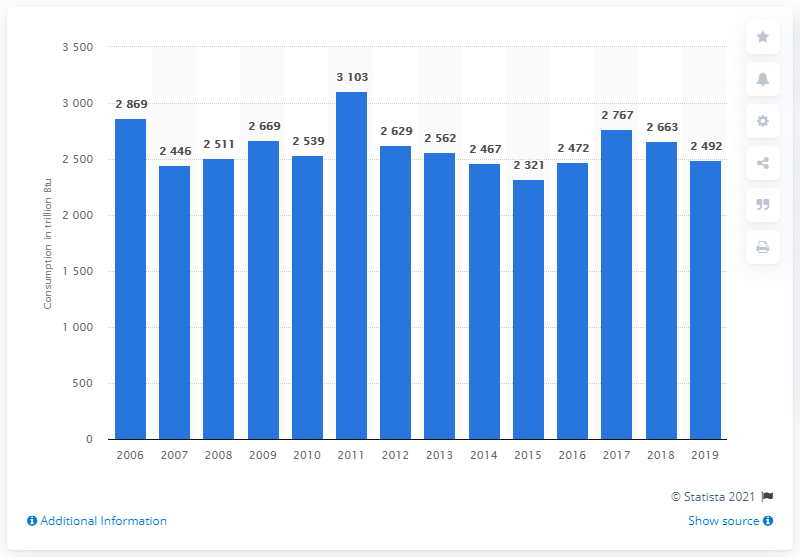Highlight a few significant elements in this photo. In the year 2016, the United States consumed 2.5 quadrillion British thermal units of hydropower. 